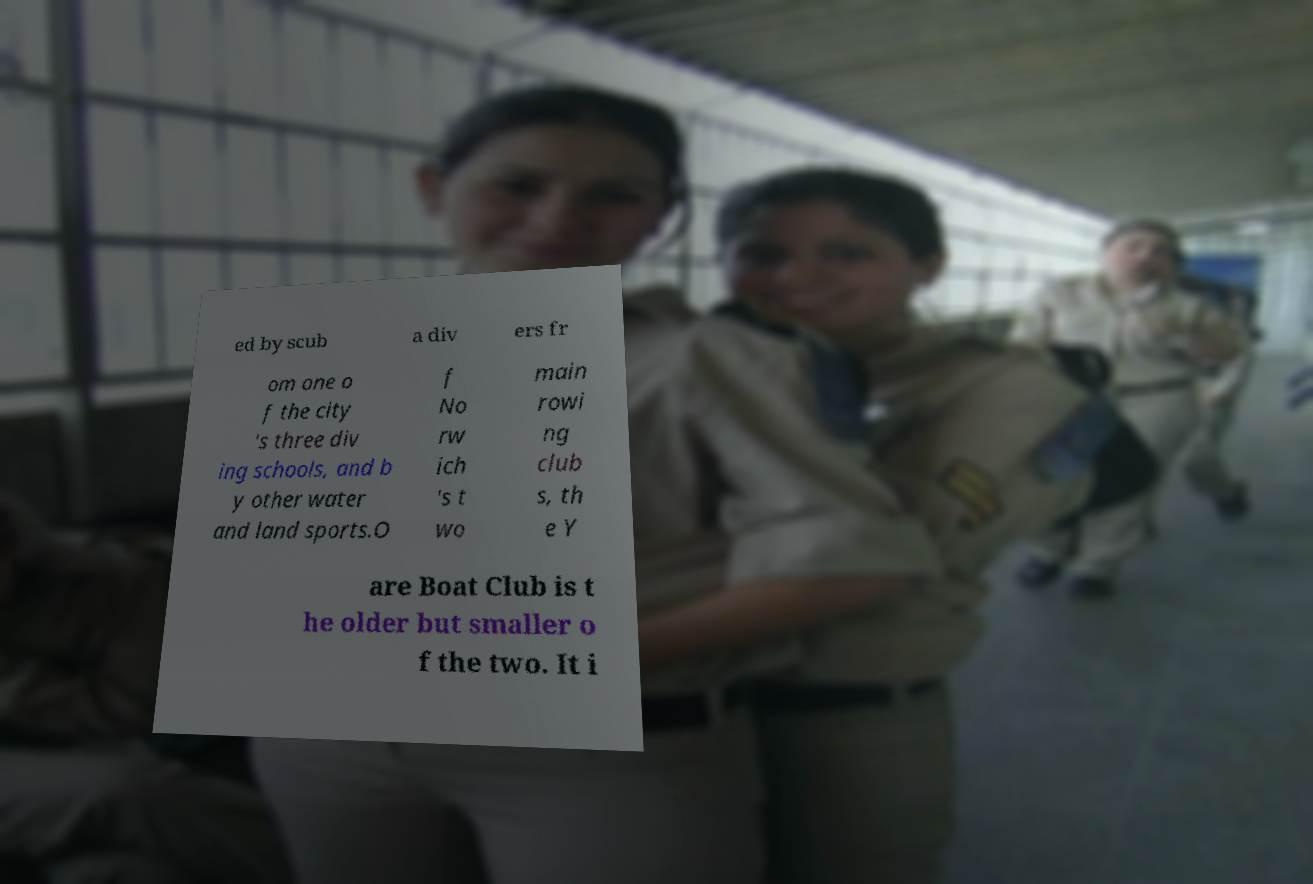Could you assist in decoding the text presented in this image and type it out clearly? ed by scub a div ers fr om one o f the city 's three div ing schools, and b y other water and land sports.O f No rw ich 's t wo main rowi ng club s, th e Y are Boat Club is t he older but smaller o f the two. It i 